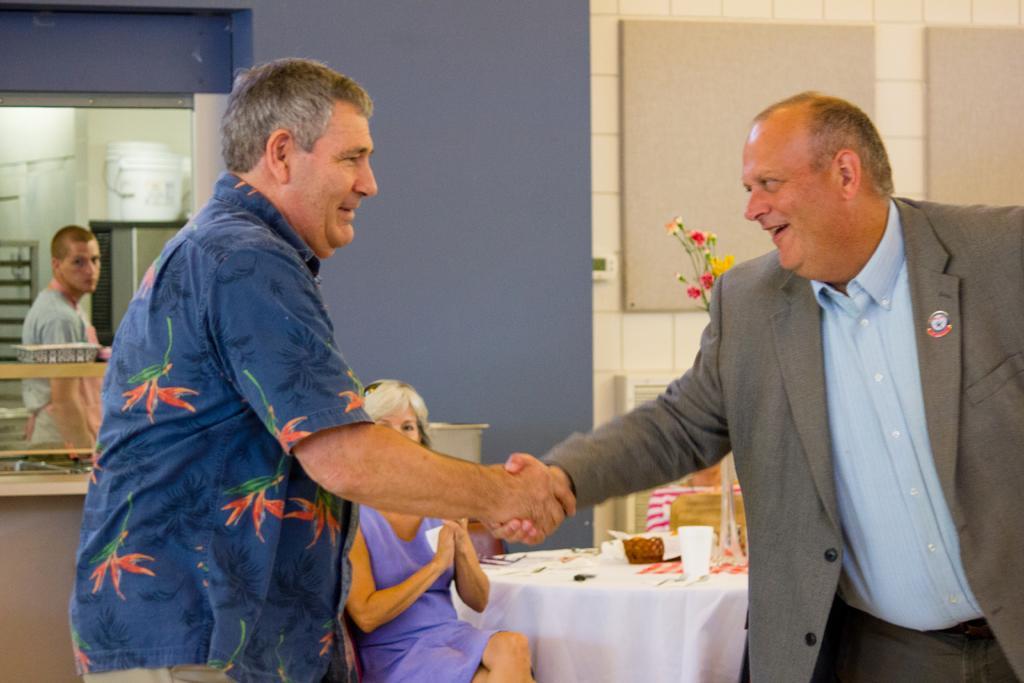Can you describe this image briefly? In this image, we can see people and one of them is holding hands of another person. In the background, there is a flower vase and some objects and a cloth are on the table and we can see some stands and there are buckets and there is a wall. There is a lady sitting on the chair. 